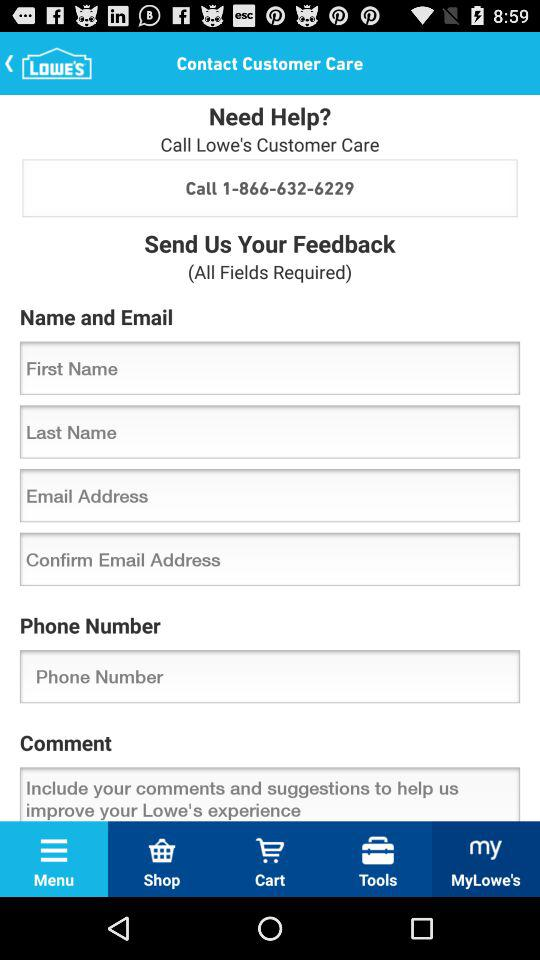Which tab is selected? The selected tab is "Menu". 